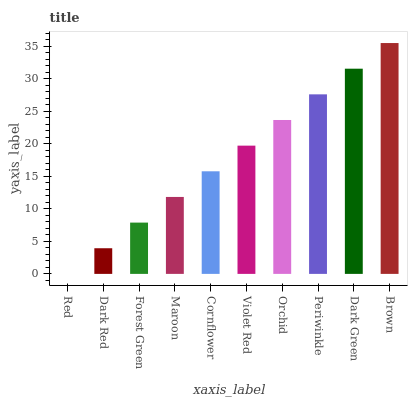Is Red the minimum?
Answer yes or no. Yes. Is Brown the maximum?
Answer yes or no. Yes. Is Dark Red the minimum?
Answer yes or no. No. Is Dark Red the maximum?
Answer yes or no. No. Is Dark Red greater than Red?
Answer yes or no. Yes. Is Red less than Dark Red?
Answer yes or no. Yes. Is Red greater than Dark Red?
Answer yes or no. No. Is Dark Red less than Red?
Answer yes or no. No. Is Violet Red the high median?
Answer yes or no. Yes. Is Cornflower the low median?
Answer yes or no. Yes. Is Maroon the high median?
Answer yes or no. No. Is Brown the low median?
Answer yes or no. No. 